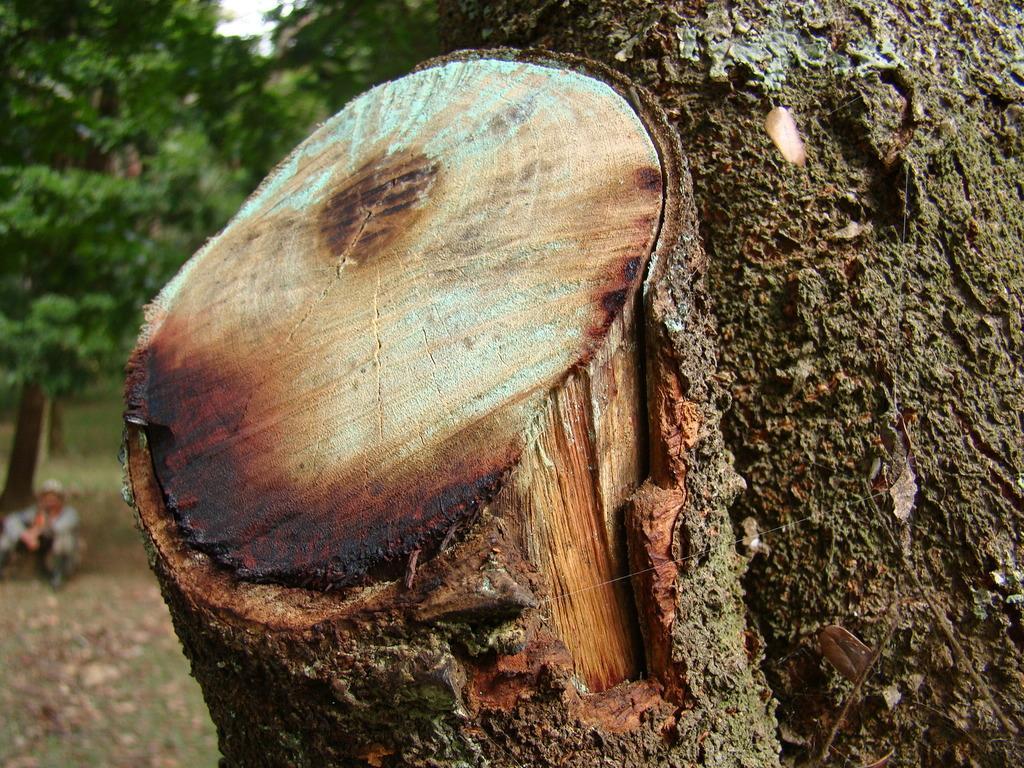How would you summarize this image in a sentence or two? In this image we can see the tree trunk. The background of the image is blurred, where we can see a person here and trees. 